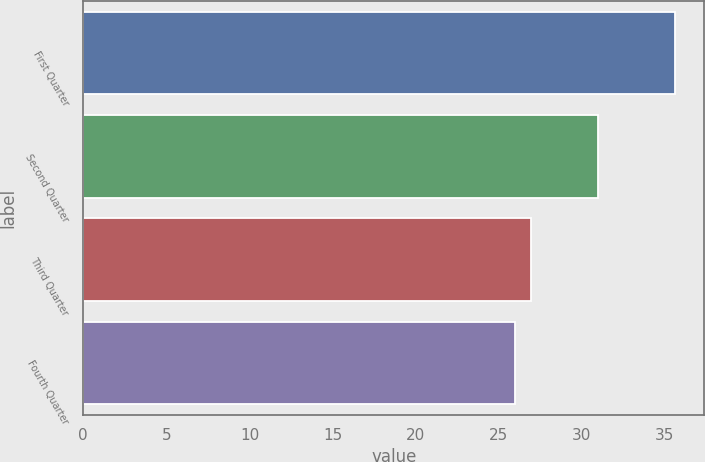Convert chart. <chart><loc_0><loc_0><loc_500><loc_500><bar_chart><fcel>First Quarter<fcel>Second Quarter<fcel>Third Quarter<fcel>Fourth Quarter<nl><fcel>35.6<fcel>30.95<fcel>26.95<fcel>25.99<nl></chart> 